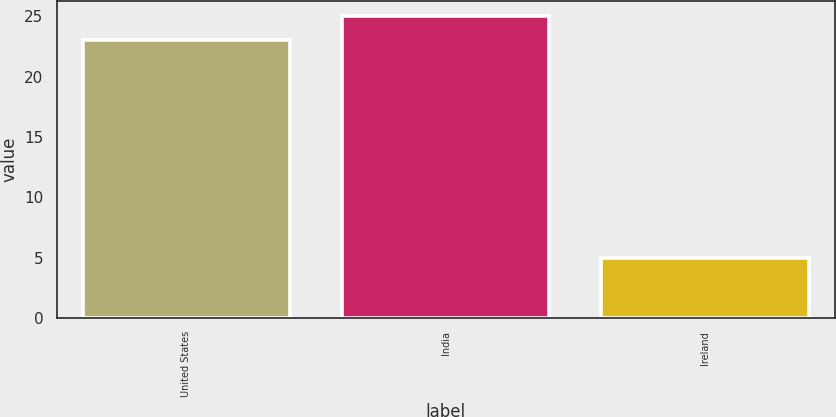Convert chart. <chart><loc_0><loc_0><loc_500><loc_500><bar_chart><fcel>United States<fcel>India<fcel>Ireland<nl><fcel>23<fcel>25<fcel>5<nl></chart> 